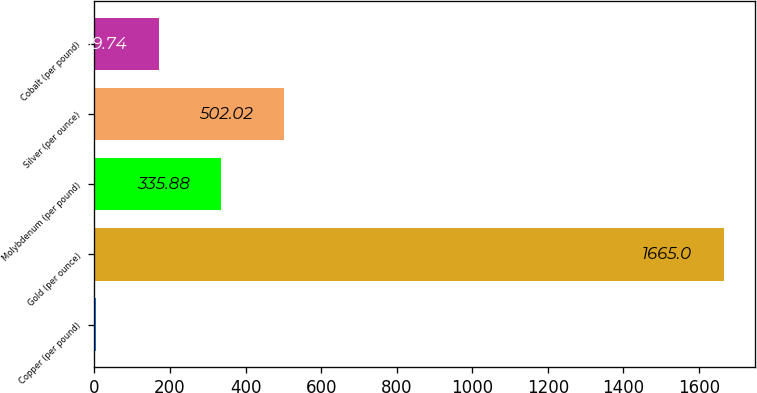<chart> <loc_0><loc_0><loc_500><loc_500><bar_chart><fcel>Copper (per pound)<fcel>Gold (per ounce)<fcel>Molybdenum (per pound)<fcel>Silver (per ounce)<fcel>Cobalt (per pound)<nl><fcel>3.6<fcel>1665<fcel>335.88<fcel>502.02<fcel>169.74<nl></chart> 